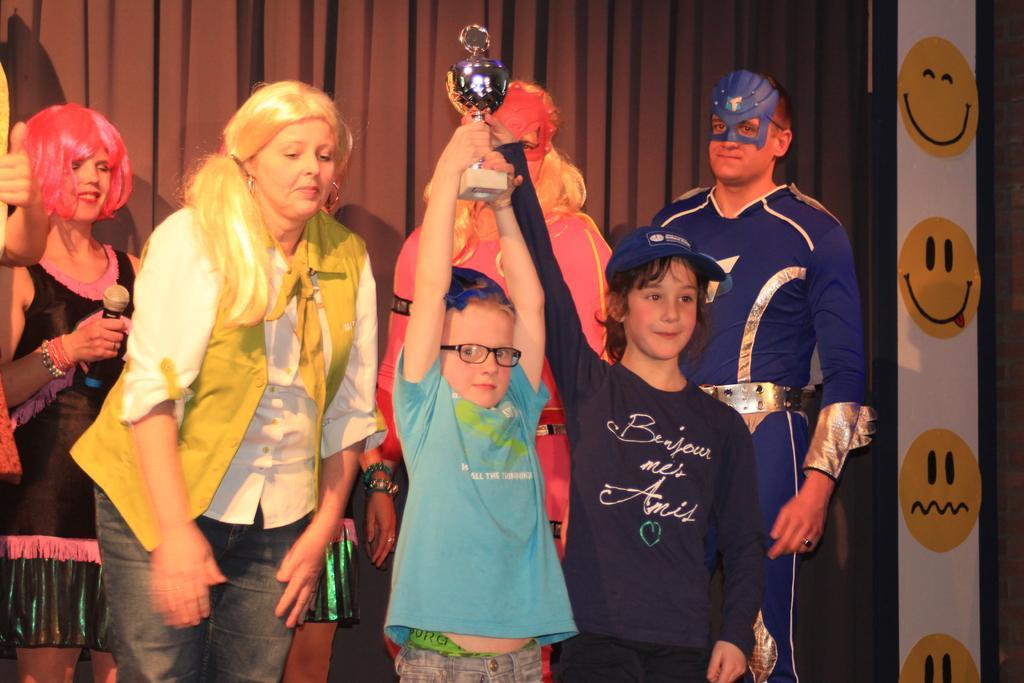Describe this image in one or two sentences. This picture describes about group of people, few people wore costumes, in the middle of the image we can see a boy, he wore spectacles and he is holding a shield, on the left side of the image we can see a woman, she is holding a microphone, in the background we can see curtains. 